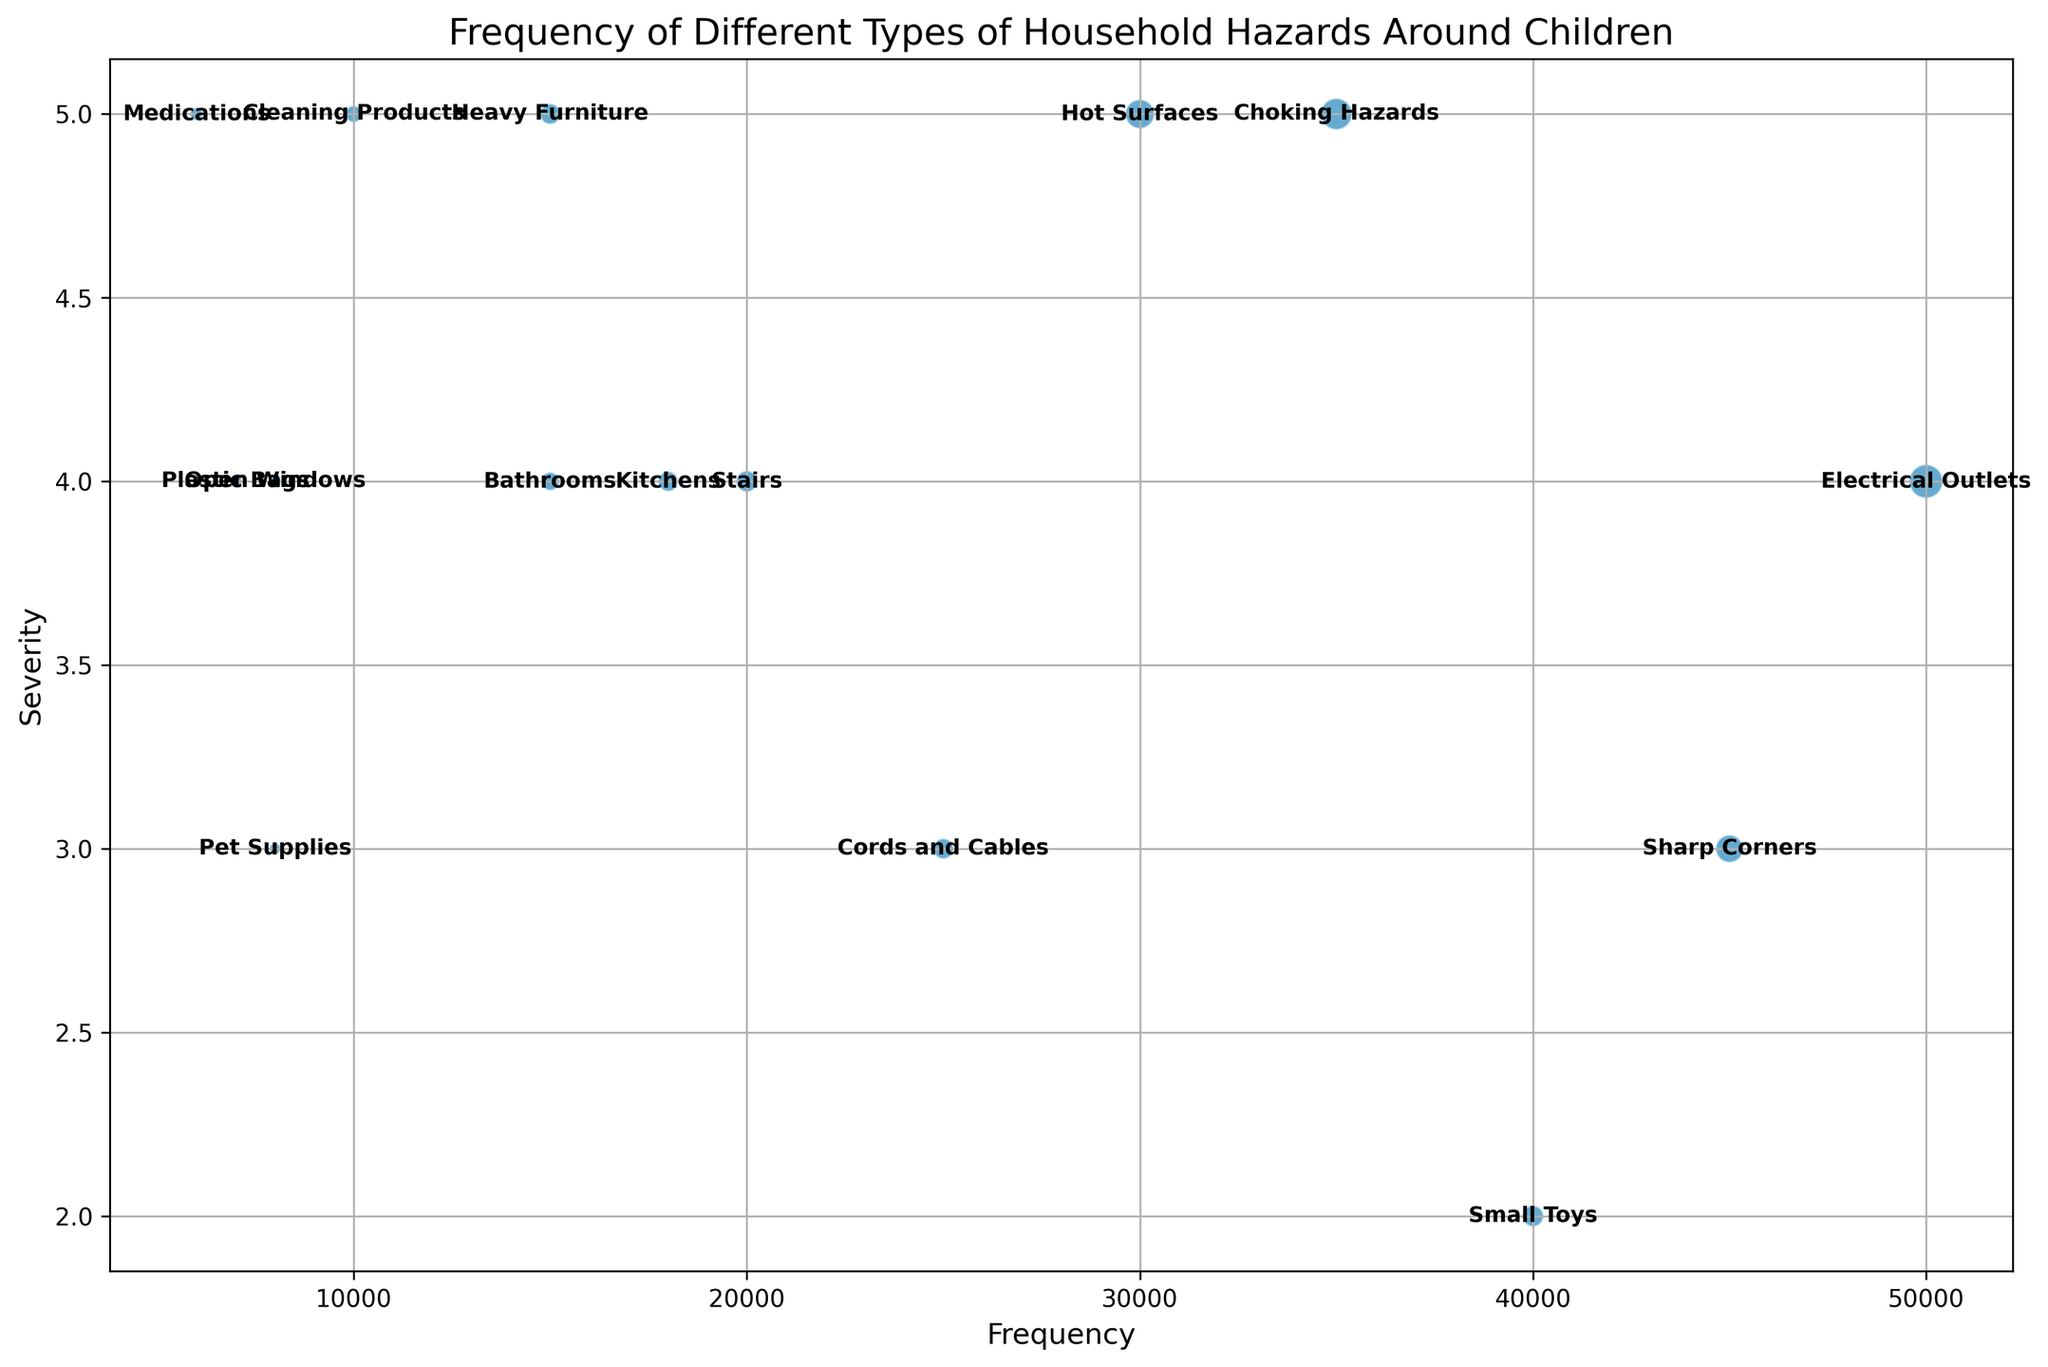Which hazard has the highest frequency? Look for the bubble that is farthest to the right on the x-axis, indicating the highest occurrence. The "Electrical Outlets" bubble is positioned the farthest to the right.
Answer: Electrical Outlets Which hazard has the highest severity? Identify the bubble that is highest on the y-axis, indicating the most severe type. The "Choking Hazards" bubble is the highest.
Answer: Choking Hazards Which hazard type has the largest bubble size? The size of the bubble is proportional to the impact, so look for the largest bubble on the chart. The largest bubble corresponds to "Electrical Outlets."
Answer: Electrical Outlets Do hot surfaces and heavy furniture have the same severity? Compare the vertical positions (y-values) of the bubbles for "Hot Surfaces" and "Heavy Furniture." Both are positioned at y = 5.
Answer: Yes Which hazard has the smallest impact? Look for the smallest bubble on the chart in terms of size. The smallest bubble corresponds to "Medications."
Answer: Medications Which hazard has a higher frequency, small toys, or choking hazards? Compare the horizontal positions (x-values) of the bubbles for "Small Toys" and "Choking Hazards." "Small Toys" has an x-value of 40000, whereas "Choking Hazards" has an x-value of 35000.
Answer: Small Toys Which hazard has a greater frequency, stairs or bathrooms? Compare the positions along the x-axis. "Stairs" has a frequency of 20000, and "Bathrooms" has a frequency of 15000.
Answer: Stairs Name a hazard with a frequency greater than 20000 but less than 50000 and the severity between 2 and 4. Identify the bubbles within the specified x and y ranges. "Sharp Corners" meets the criteria with a frequency of 45000 and severity 3.
Answer: Sharp Corners What is the combined impact of sharp corners and hot surfaces? Sum the impacts of "Sharp Corners" (135000) and "Hot Surfaces" (150000). Combined impact is 135000 + 150000.
Answer: 285000 Which has a higher severity, electrical outlets or open windows? Compare the vertical positions of the bubbles. "Electrical Outlets" has a severity of 4, while "Open Windows" also has a severity of 4.
Answer: Both have the same severity 